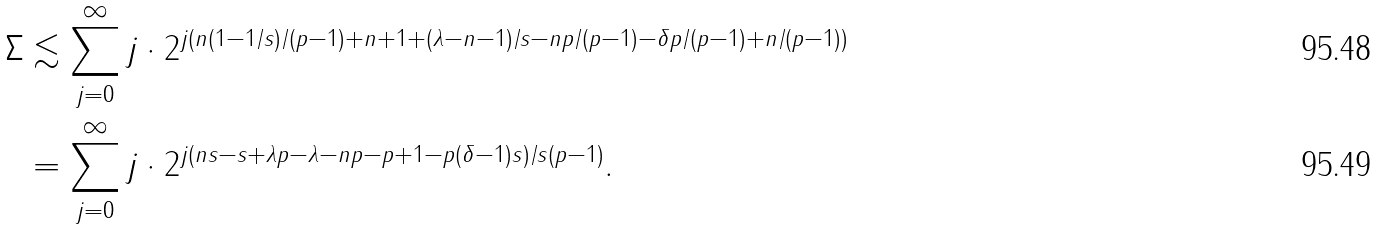Convert formula to latex. <formula><loc_0><loc_0><loc_500><loc_500>\Sigma & \lesssim \sum _ { j = 0 } ^ { \infty } j \cdot 2 ^ { j ( n ( 1 - 1 / s ) / ( p - 1 ) + n + 1 + ( \lambda - n - 1 ) / s - n p / ( p - 1 ) - \delta p / ( p - 1 ) + n / ( p - 1 ) ) } \\ & = \sum _ { j = 0 } ^ { \infty } j \cdot 2 ^ { j ( n s - s + \lambda p - \lambda - n p - p + 1 - p ( \delta - 1 ) s ) / s ( p - 1 ) } .</formula> 